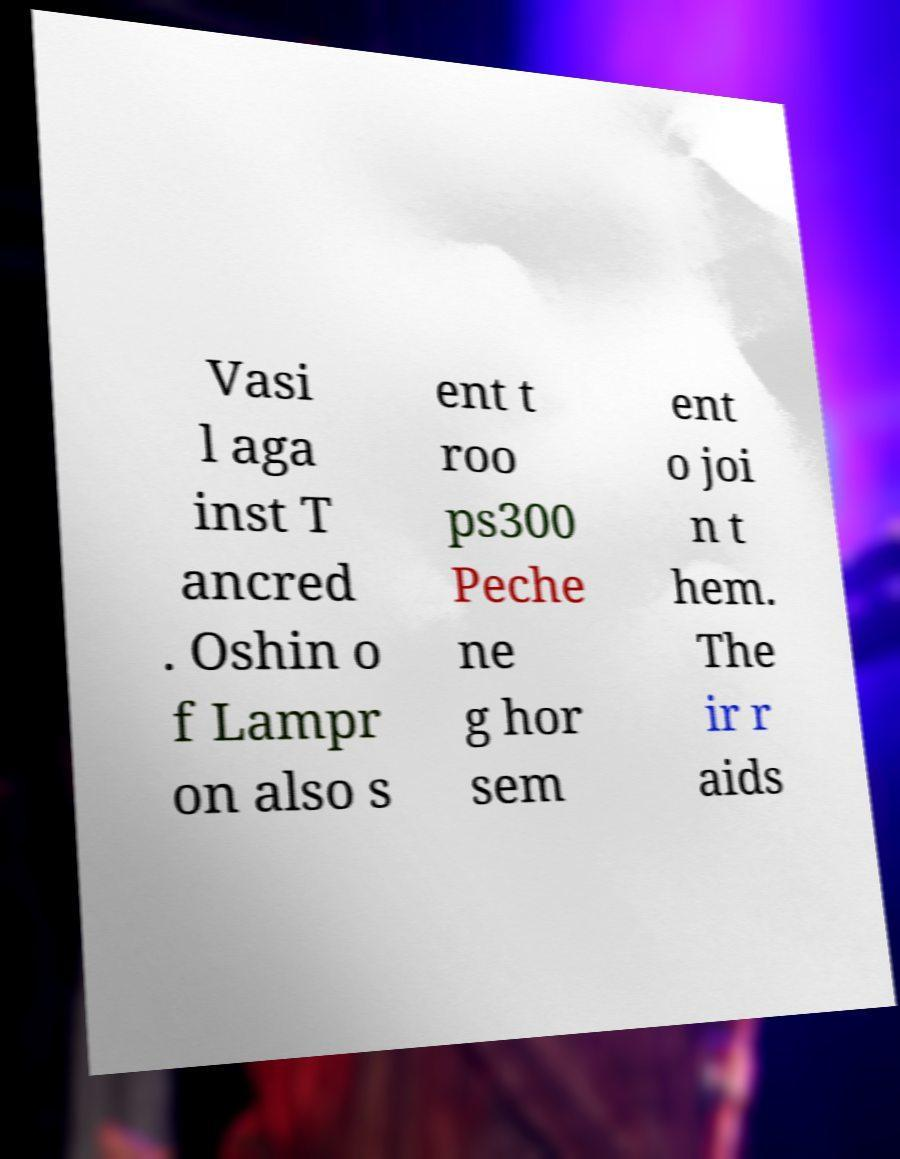Please read and relay the text visible in this image. What does it say? Vasi l aga inst T ancred . Oshin o f Lampr on also s ent t roo ps300 Peche ne g hor sem ent o joi n t hem. The ir r aids 